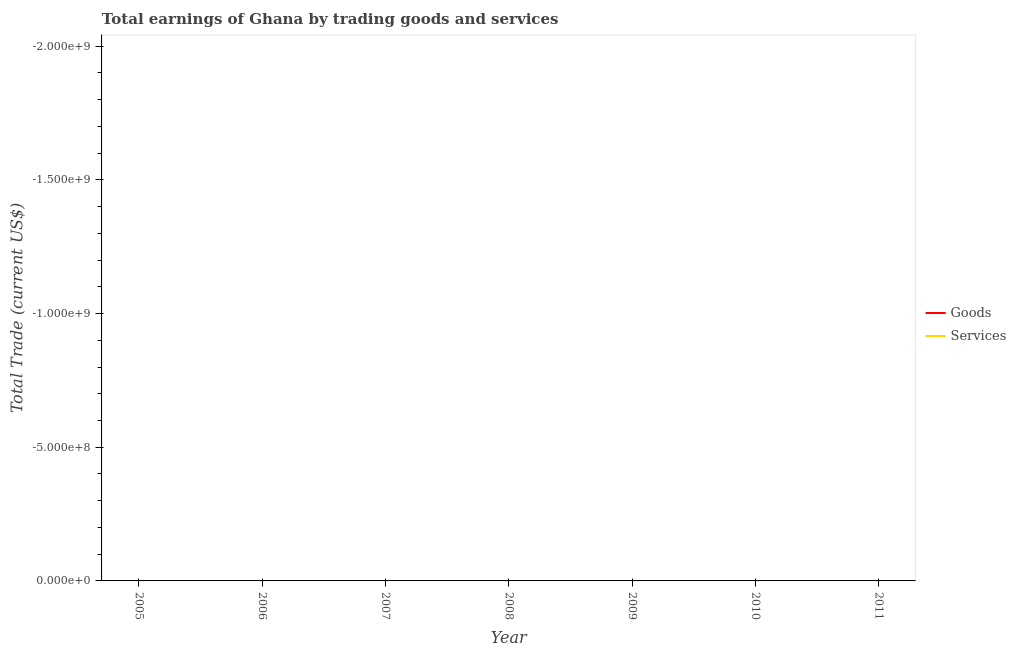How many different coloured lines are there?
Provide a succinct answer. 0. Does the line corresponding to amount earned by trading goods intersect with the line corresponding to amount earned by trading services?
Ensure brevity in your answer.  No. Is the number of lines equal to the number of legend labels?
Give a very brief answer. No. What is the amount earned by trading services in 2007?
Offer a terse response. 0. What is the total amount earned by trading goods in the graph?
Ensure brevity in your answer.  0. What is the difference between the amount earned by trading goods in 2005 and the amount earned by trading services in 2010?
Your answer should be very brief. 0. In how many years, is the amount earned by trading services greater than the average amount earned by trading services taken over all years?
Offer a very short reply. 0. Is the amount earned by trading goods strictly greater than the amount earned by trading services over the years?
Provide a short and direct response. Yes. How many years are there in the graph?
Offer a very short reply. 7. What is the difference between two consecutive major ticks on the Y-axis?
Offer a terse response. 5.00e+08. Are the values on the major ticks of Y-axis written in scientific E-notation?
Keep it short and to the point. Yes. What is the title of the graph?
Ensure brevity in your answer.  Total earnings of Ghana by trading goods and services. Does "Excluding technical cooperation" appear as one of the legend labels in the graph?
Ensure brevity in your answer.  No. What is the label or title of the X-axis?
Offer a terse response. Year. What is the label or title of the Y-axis?
Make the answer very short. Total Trade (current US$). What is the Total Trade (current US$) in Goods in 2005?
Your response must be concise. 0. What is the Total Trade (current US$) of Services in 2005?
Offer a terse response. 0. What is the Total Trade (current US$) in Goods in 2006?
Your answer should be compact. 0. What is the Total Trade (current US$) in Services in 2007?
Your answer should be very brief. 0. What is the Total Trade (current US$) of Goods in 2008?
Ensure brevity in your answer.  0. What is the Total Trade (current US$) in Goods in 2009?
Offer a terse response. 0. What is the Total Trade (current US$) in Services in 2009?
Your answer should be very brief. 0. What is the Total Trade (current US$) of Goods in 2010?
Give a very brief answer. 0. What is the Total Trade (current US$) of Goods in 2011?
Your answer should be compact. 0. What is the Total Trade (current US$) in Services in 2011?
Your answer should be compact. 0. What is the total Total Trade (current US$) in Goods in the graph?
Your response must be concise. 0. What is the total Total Trade (current US$) of Services in the graph?
Keep it short and to the point. 0. 